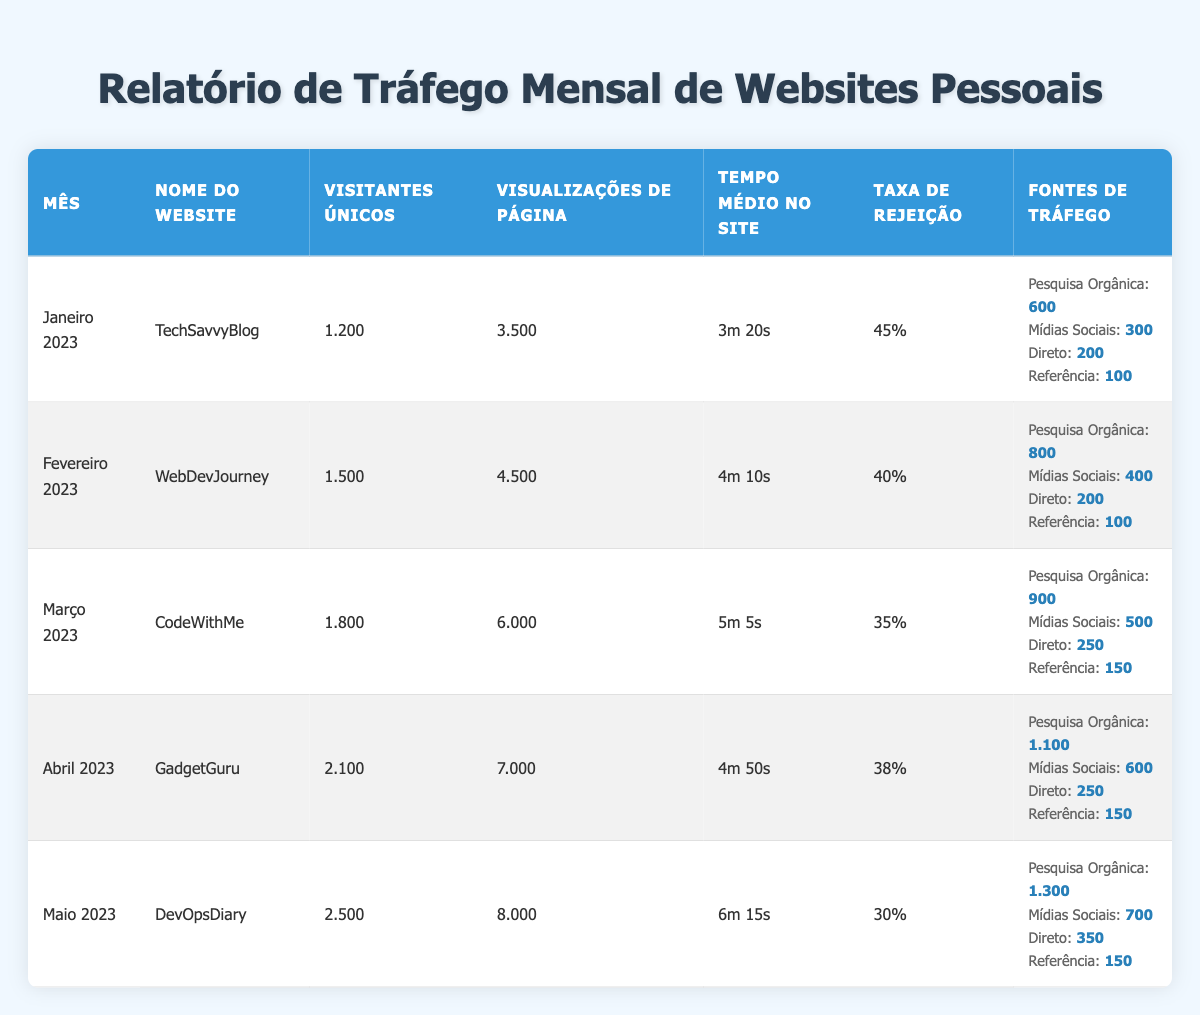Qual foi o mês com o maior número de visitantes únicos? Ao observar a tabela, o mês com o maior número de visitantes únicos é "Maio 2023", que tem 2.500 visitantes únicos.
Answer: Maio 2023 Qual foi a taxa de rejeição para o "CodeWithMe"? A taxa de rejeição para "CodeWithMe", que é o site de março de 2023, é de 35%.
Answer: 35% Qual é a média de visualizações de página dos sites listados? Somando as visualizações de página: 3.500 + 4.500 + 6.000 + 7.000 + 8.000 = 29.000. Dividindo por 5 (número de meses), temos uma média de 29.000/5 = 5.800 visualizações de página.
Answer: 5.800 O "GadgetGuru" teve mais visitas únicas que o "WebDevJourney"? Comparando os dados, "GadgetGuru" teve 2.100 visitantes únicos e "WebDevJourney" teve 1.500 visitantes únicos. Portanto, sim, "GadgetGuru" teve mais visitantes únicos.
Answer: Sim Qual foi o maior tempo médio no site e de qual mês ele é? O maior tempo médio no site é de "6m 15s", que corresponde ao mês de "Maio 2023".
Answer: 6m 15s, Maio 2023 Quantos visitantes únicos foram gerados através de pesquisa orgânica em Abril 2023? De acordo com os dados, em Abril 2023, o site "GadgetGuru" teve 1.100 visitantes únicos provenientes de pesquisa orgânica.
Answer: 1.100 O "DevOpsDiary" recebeu mais visitantes diretos do que o "TechSavvyBlog"? "DevOpsDiary" teve 350 visitantes diretos enquanto "TechSavvyBlog" teve 200. Logo, sim, "DevOpsDiary" recebeu mais visitantes diretos.
Answer: Sim Qual foi o total de visualizações de página de todos os sites no relatório? Somando todas as visualizações de página: 3.500 + 4.500 + 6.000 + 7.000 + 8.000 = 29.000 visualizações de página totais.
Answer: 29.000 Qual foi a diminuição na taxa de rejeição de janeiro para maio? A taxa de rejeição em janeiro era de 45% e em maio era de 30%. A diminuição é de 45% - 30% = 15%.
Answer: 15% 